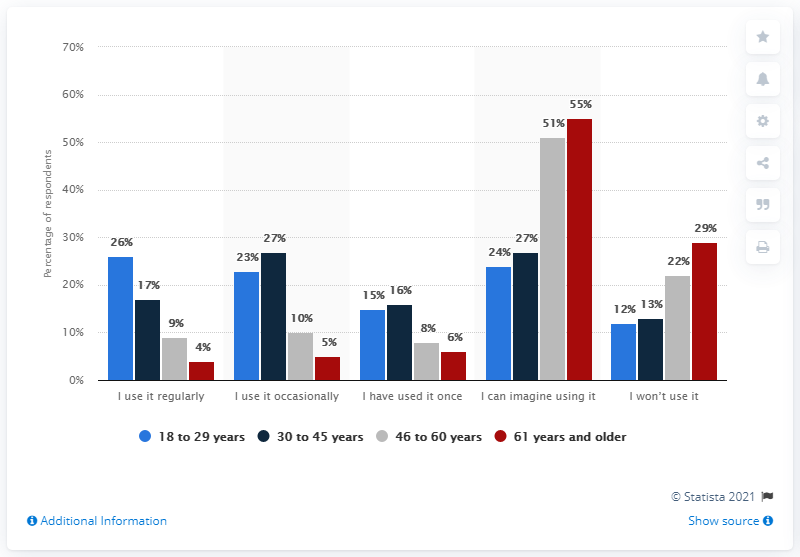Draw attention to some important aspects in this diagram. According to a survey conducted in 2017, about 46% to 60% of adults in the United States were able to envision using a mobile app to track their diet and nutrition. According to data from 2017, approximately 51% of adults in the United States between the ages of 46 and 60 were able to envision using an app to track their diet and nutrition. 